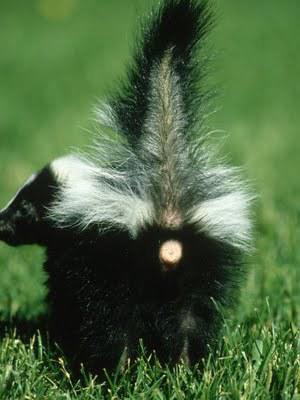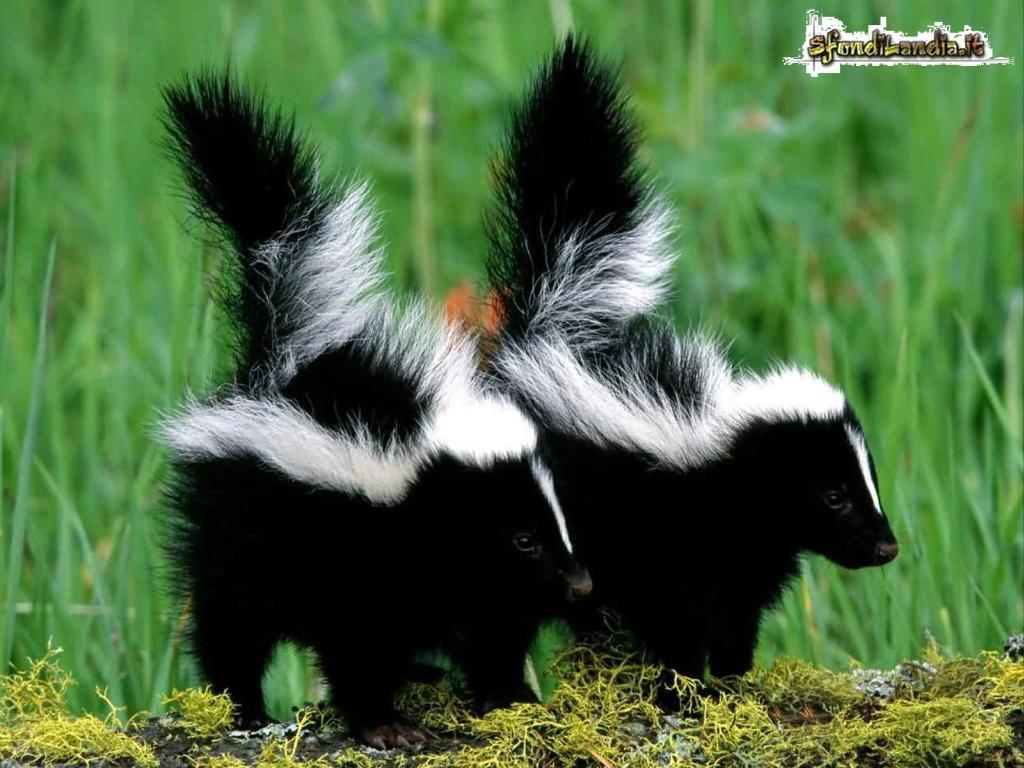The first image is the image on the left, the second image is the image on the right. For the images displayed, is the sentence "There are no more than four skunks in total." factually correct? Answer yes or no. Yes. The first image is the image on the left, the second image is the image on the right. Evaluate the accuracy of this statement regarding the images: "There is a single skunk in the right image.". Is it true? Answer yes or no. No. 